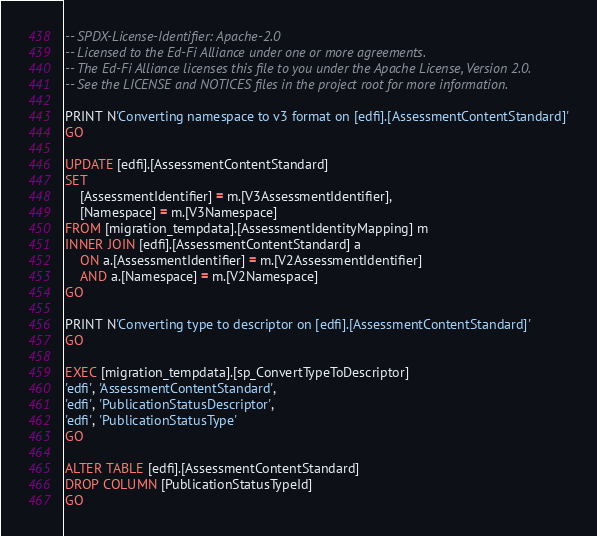<code> <loc_0><loc_0><loc_500><loc_500><_SQL_>-- SPDX-License-Identifier: Apache-2.0
-- Licensed to the Ed-Fi Alliance under one or more agreements.
-- The Ed-Fi Alliance licenses this file to you under the Apache License, Version 2.0.
-- See the LICENSE and NOTICES files in the project root for more information.

PRINT N'Converting namespace to v3 format on [edfi].[AssessmentContentStandard]'
GO

UPDATE [edfi].[AssessmentContentStandard]
SET
	[AssessmentIdentifier] = m.[V3AssessmentIdentifier],
	[Namespace] = m.[V3Namespace]
FROM [migration_tempdata].[AssessmentIdentityMapping] m
INNER JOIN [edfi].[AssessmentContentStandard] a
	ON a.[AssessmentIdentifier] = m.[V2AssessmentIdentifier]
	AND a.[Namespace] = m.[V2Namespace]
GO

PRINT N'Converting type to descriptor on [edfi].[AssessmentContentStandard]'
GO

EXEC [migration_tempdata].[sp_ConvertTypeToDescriptor]
'edfi', 'AssessmentContentStandard',
'edfi', 'PublicationStatusDescriptor',
'edfi', 'PublicationStatusType'
GO

ALTER TABLE [edfi].[AssessmentContentStandard]
DROP COLUMN [PublicationStatusTypeId]
GO</code> 